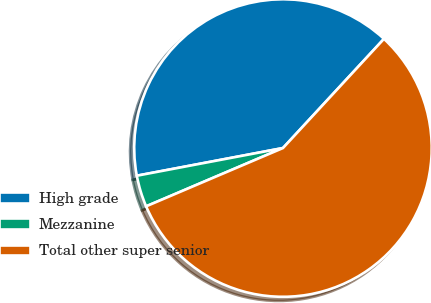Convert chart. <chart><loc_0><loc_0><loc_500><loc_500><pie_chart><fcel>High grade<fcel>Mezzanine<fcel>Total other super senior<nl><fcel>39.86%<fcel>3.43%<fcel>56.71%<nl></chart> 